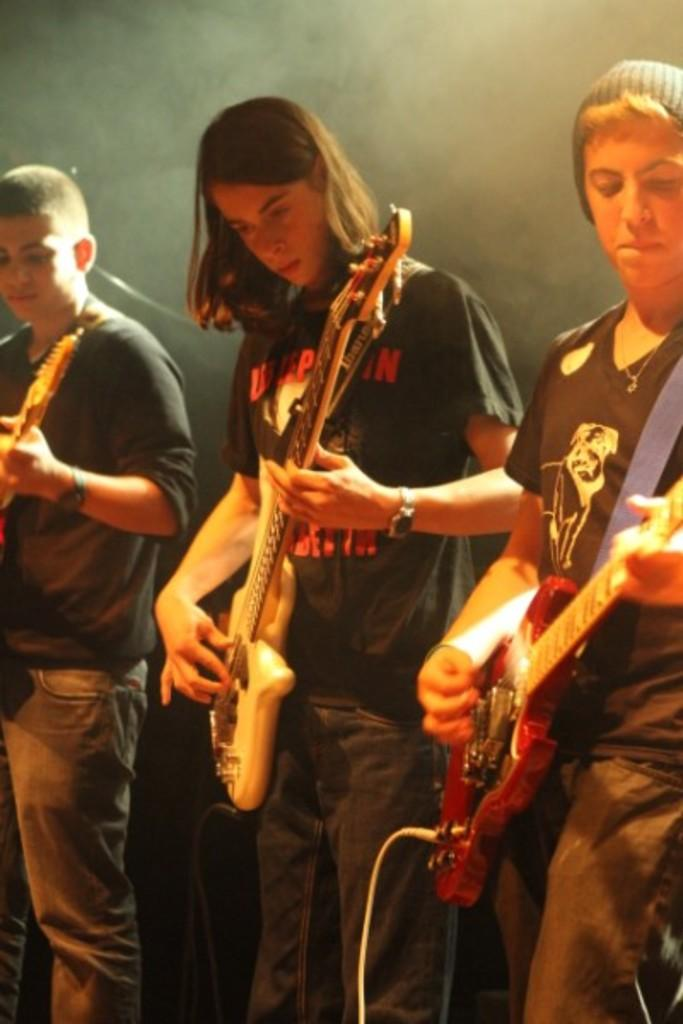How many people are in the image? There are three persons in the image. What are the persons doing in the image? The persons are standing and holding music instruments. What can be seen in the background of the image? There is a black color wall in the background of the image. How long does it take for the organization to respond in the image? There is no organization present in the image, and therefore no response time can be determined. 